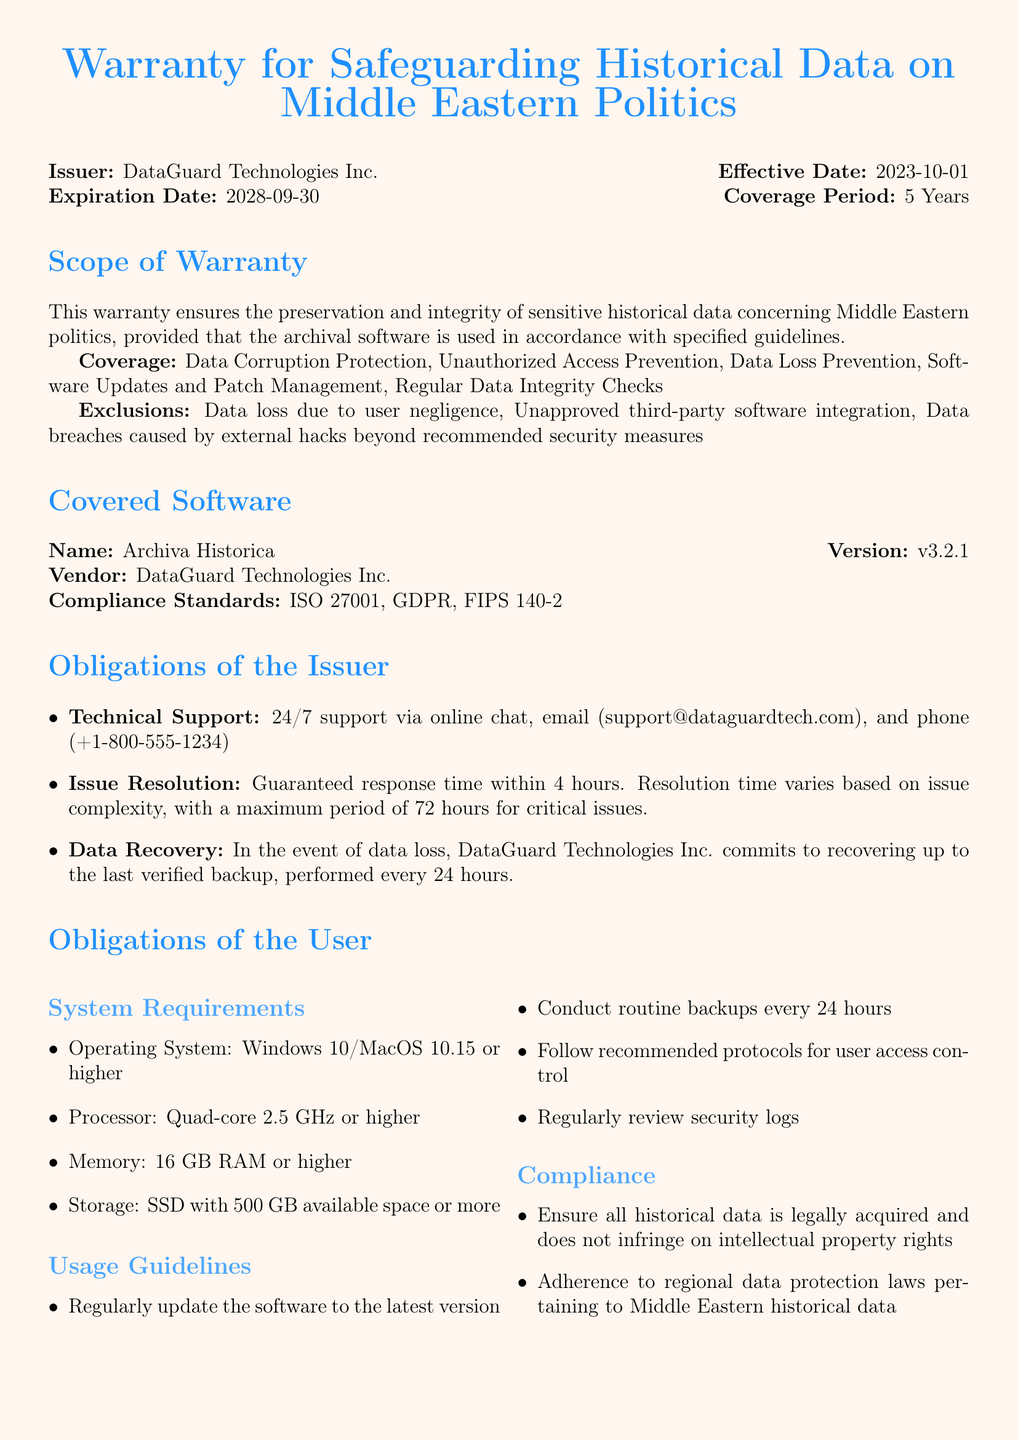What is the issuer of the warranty? The issuer is mentioned at the beginning of the document, identifying the entity responsible for the warranty.
Answer: DataGuard Technologies Inc What is the effective date of the warranty? The effective date is listed in the document, indicating when the warranty comes into force.
Answer: 2023-10-01 What is the expiration date of the warranty? The expiration date specifies when the warranty will no longer be valid.
Answer: 2028-09-30 What is the coverage period of the warranty? The coverage period is detailed to show how long the warranty will last.
Answer: 5 Years Which software is covered under this warranty? The document specifies the name of the software that is under warranty coverage.
Answer: Archiva Historica What are the compliance standards mentioned? The compliance standards are indicated to show the regulatory benchmarks the software adheres to.
Answer: ISO 27001, GDPR, FIPS 140-2 What is the guaranteed response time for issue resolution? The document includes a commitment regarding response time for addressing issues under the warranty.
Answer: 4 hours What will void the warranty? The document lists conditions that would lead to termination of the warranty.
Answer: Failure to adhere to usage guidelines What kind of technical support is provided? The warranty outlines the type of support users can expect for the covered software.
Answer: 24/7 support via online chat, email, and phone 